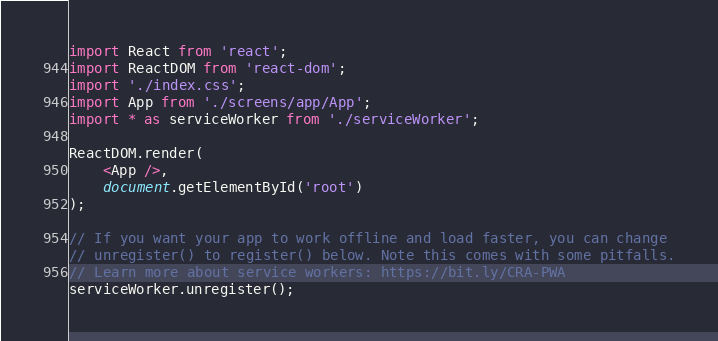Convert code to text. <code><loc_0><loc_0><loc_500><loc_500><_TypeScript_>import React from 'react';
import ReactDOM from 'react-dom';
import './index.css';
import App from './screens/app/App';
import * as serviceWorker from './serviceWorker';

ReactDOM.render(
    <App />,
    document.getElementById('root')
);

// If you want your app to work offline and load faster, you can change
// unregister() to register() below. Note this comes with some pitfalls.
// Learn more about service workers: https://bit.ly/CRA-PWA
serviceWorker.unregister();
</code> 